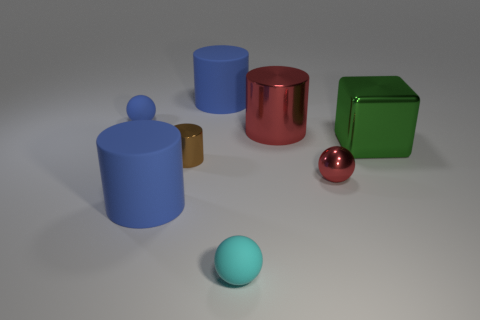There is a cyan ball that is the same size as the brown object; what material is it?
Give a very brief answer. Rubber. What number of brown metal things are behind the tiny brown metal thing?
Your answer should be very brief. 0. Is the shape of the red metal thing that is in front of the brown thing the same as  the tiny cyan matte object?
Your answer should be very brief. Yes. Are there any tiny brown objects that have the same shape as the large green shiny object?
Provide a succinct answer. No. There is a big thing that is the same color as the small metallic sphere; what is it made of?
Offer a terse response. Metal. There is a rubber object that is on the right side of the large rubber object that is behind the red metal sphere; what is its shape?
Ensure brevity in your answer.  Sphere. What number of tiny blue balls are the same material as the red sphere?
Ensure brevity in your answer.  0. There is a tiny sphere that is the same material as the big red cylinder; what color is it?
Make the answer very short. Red. How big is the cylinder behind the tiny rubber thing that is behind the small shiny thing that is in front of the small brown thing?
Keep it short and to the point. Large. Are there fewer large red metal objects than yellow metallic cubes?
Make the answer very short. No. 